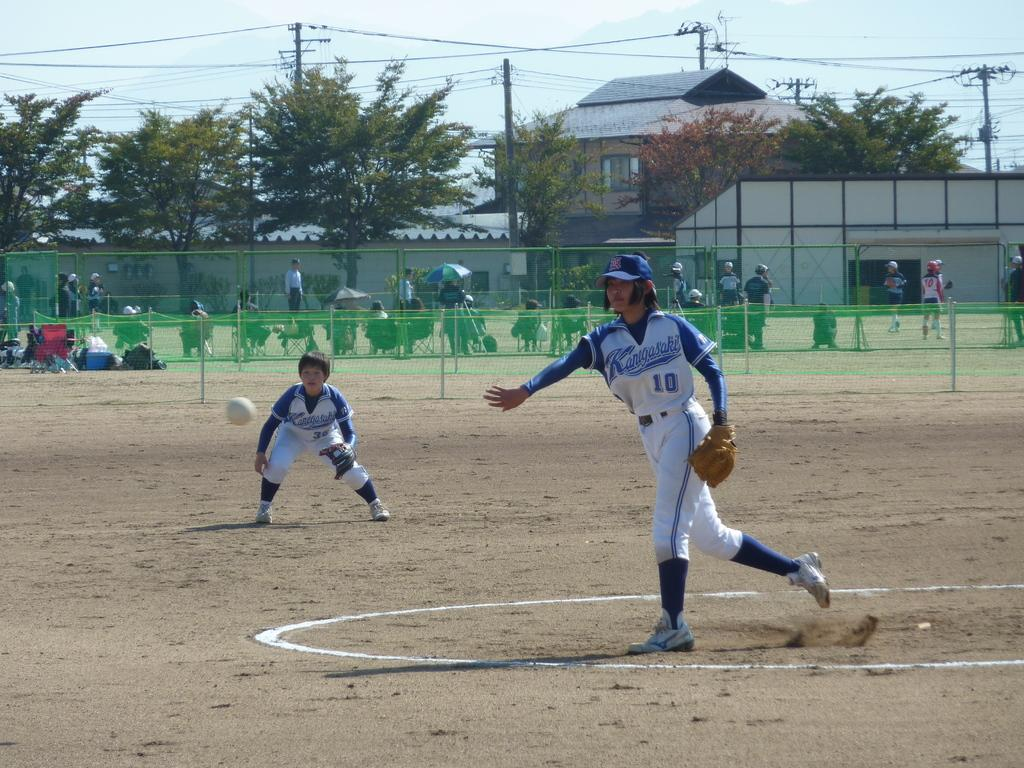<image>
Relay a brief, clear account of the picture shown. A player wearing a Kangasaki jersey throws the ball. 